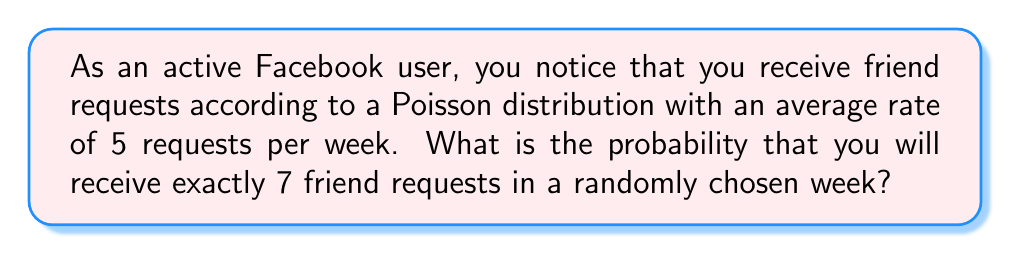What is the answer to this math problem? Let's approach this step-by-step:

1) The Poisson distribution is given by the formula:

   $$P(X = k) = \frac{e^{-\lambda} \lambda^k}{k!}$$

   where:
   - $\lambda$ is the average rate of events
   - $k$ is the number of events we're interested in
   - $e$ is Euler's number (approximately 2.71828)

2) In this case:
   - $\lambda = 5$ (average of 5 requests per week)
   - $k = 7$ (we're interested in exactly 7 requests)

3) Let's substitute these values into the formula:

   $$P(X = 7) = \frac{e^{-5} 5^7}{7!}$$

4) Now, let's calculate step by step:

   - $e^{-5} \approx 0.00673795$
   - $5^7 = 78125$
   - $7! = 7 \times 6 \times 5 \times 4 \times 3 \times 2 \times 1 = 5040$

5) Putting it all together:

   $$P(X = 7) = \frac{0.00673795 \times 78125}{5040} \approx 0.1041$$

6) Therefore, the probability of receiving exactly 7 friend requests in a randomly chosen week is approximately 0.1041 or 10.41%.
Answer: $0.1041$ or $10.41\%$ 